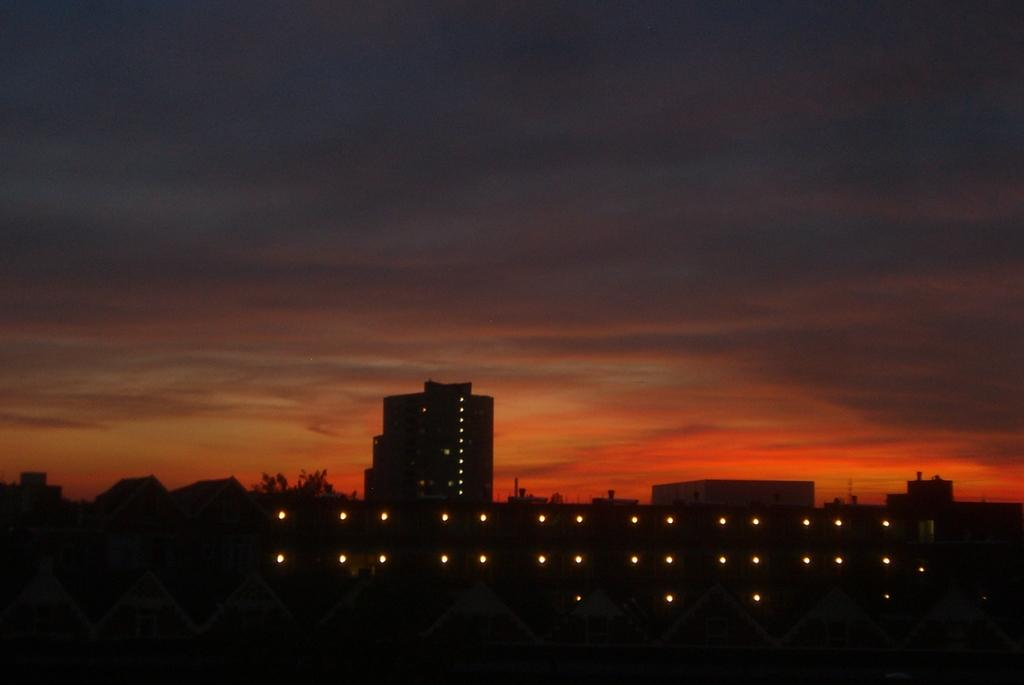What is arranged in the image? Lights are arranged in the image. What can be seen on the buildings in the background? There are lights on a building in the background. What other structures are visible in the background? There are buildings in the background. What type of natural elements can be seen in the background? There are trees and clouds in the sky in the background. How many visitors are present in the image? There is no mention of visitors in the image; it only features lights, buildings, trees, and clouds. 